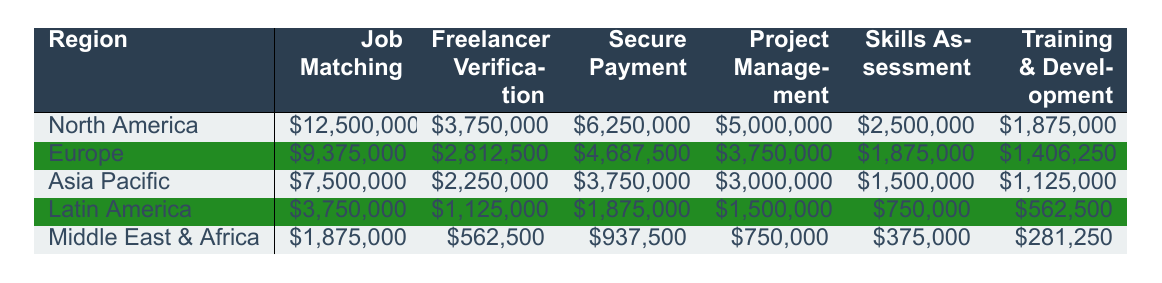What region generates the highest revenue from Job Matching? The highest revenue for Job Matching can be found by looking at the respective values for each region. North America has \$12,500,000 for Job Matching, which is the highest compared to other regions.
Answer: North America What is the total revenue from Freelancer Verification across all regions? To find the total revenue from Freelancer Verification, I add the individual revenues: \$3,750,000 (North America) + \$2,812,500 (Europe) + \$2,250,000 (Asia Pacific) + \$1,125,000 (Latin America) + \$562,500 (Middle East & Africa) = \$10,500,000.
Answer: \$10,500,000 In which region does Training & Development generate the least revenue? The revenue for Training & Development should be compared for each region. Middle East & Africa has \$281,250, which is less than the other regions' revenues for this service.
Answer: Middle East & Africa What is the difference in revenue from Secure Payment between North America and Latin America? I first find the revenue from Secure Payment for both regions: \$6,250,000 (North America) and \$1,875,000 (Latin America). The difference is calculated as \$6,250,000 - \$1,875,000 = \$4,375,000.
Answer: \$4,375,000 Which region has a combined revenue from Project Management and Skills Assessment that exceeds \$5,000,000? I will sum the revenues for Project Management and Skills Assessment for each region. North America: \$5,000,000 + \$2,500,000 = \$7,500,000; Europe: \$3,750,000 + \$1,875,000 = \$5,625,000; Asia Pacific: \$3,000,000 + \$1,500,000 = \$4,500,000; Latin America: \$1,500,000 + \$750,000 = \$2,250,000; Middle East & Africa: \$750,000 + \$375,000 = \$1,125,000. North America and Europe are over \$5,000,000.
Answer: North America and Europe Is the revenue from Skills Assessment greater in Europe than in Asia Pacific? Looking at the table, Europe has \$1,875,000 for Skills Assessment while Asia Pacific has \$1,500,000. Since \$1,875,000 is greater than \$1,500,000, the statement is true.
Answer: Yes What region has the lowest total revenue across all services? To determine the overall revenue for each region, I sum the revenues for all services: North America: \$25,625,000; Europe: \$19,031,250; Asia Pacific: \$15,375,000; Latin America: \$8,812,500; Middle East & Africa: \$5,625,000. The region with the lowest total is Middle East & Africa.
Answer: Middle East & Africa Which service type contributes the most to total revenue in North America? In North America, the revenues are \$12,500,000 (Job Matching), \$3,750,000 (Freelancer Verification), \$6,250,000 (Secure Payment), \$5,000,000 (Project Management), \$2,500,000 (Skills Assessment), and \$1,875,000 (Training & Development). The highest value is for Job Matching at \$12,500,000.
Answer: Job Matching What is the average revenue from the Training & Development service across all regions? I find the total revenue for Training & Development: \$1,875,000 (North America) + \$1,406,250 (Europe) + \$1,125,000 (Asia Pacific) + \$562,500 (Latin America) + \$281,250 (Middle East & Africa) = \$5,250,000. Dividing this by the number of regions (5), the average revenue is \$5,250,000 / 5 = \$1,050,000.
Answer: \$1,050,000 Which region has a higher total revenue: North America or Europe? Calculate the total revenue for each: North America = \$25,625,000; Europe = \$19,031,250. Since \$25,625,000 is greater than \$19,031,250, North America has a higher total.
Answer: North America 